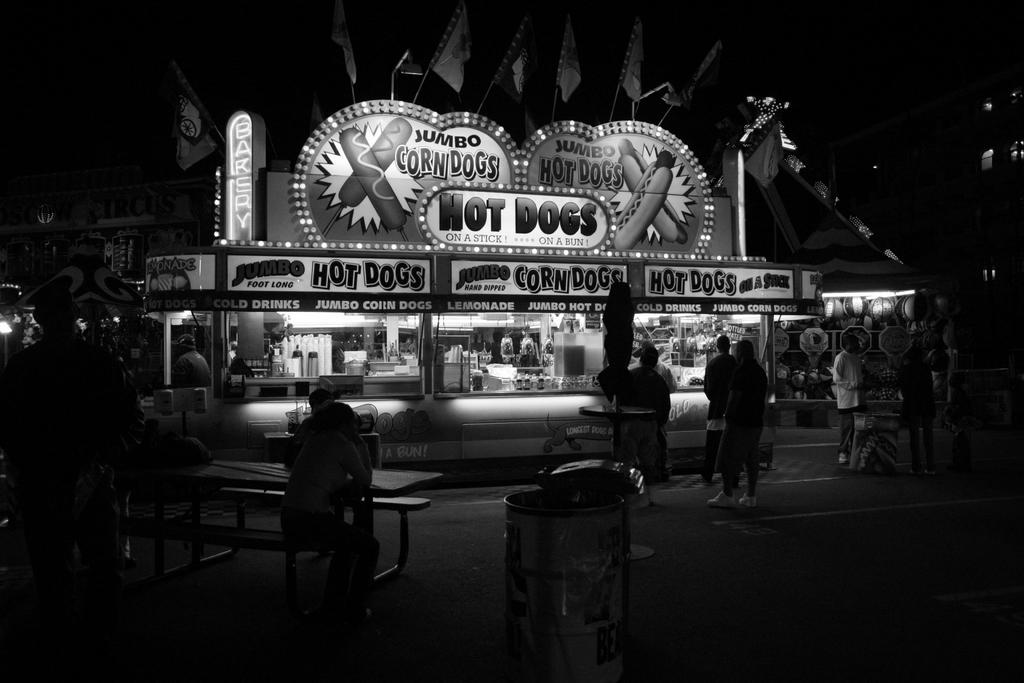<image>
Provide a brief description of the given image. A convenient store with the name Hot Dogs written above it and a few people standing around. 